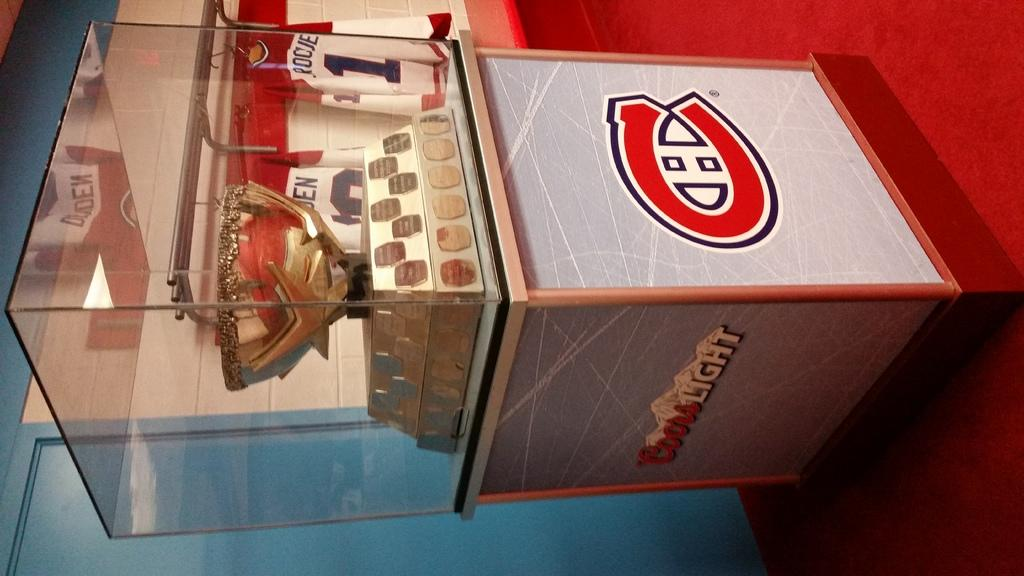What is contained within the glass in the image? There is a cup in the glass in the image. What color is the carpet that can be seen in the image? The carpet is red. What type of surface is the carpet placed on? The carpet is on a path. What can be seen in the background of the image? A wall is visible in the background of the image. How many legs can be seen on the cork in the image? There is no cork present in the image, and therefore no legs can be seen on it. 